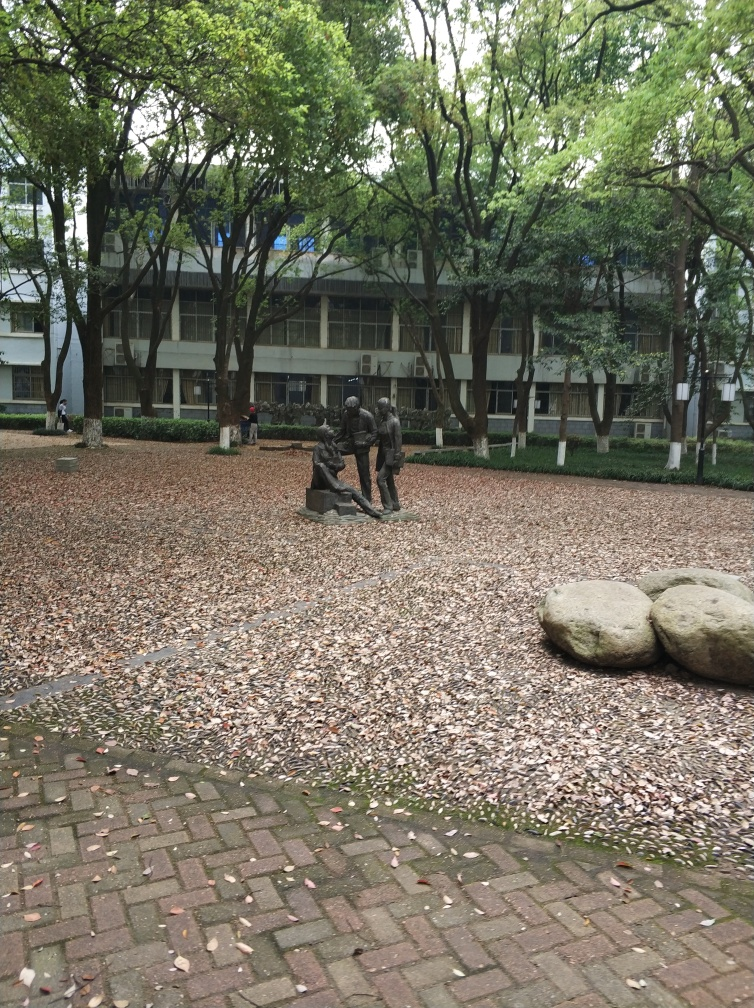Is there any distortion in the image?
A. No
B. Yes
Answer with the option's letter from the given choices directly.
 A. 